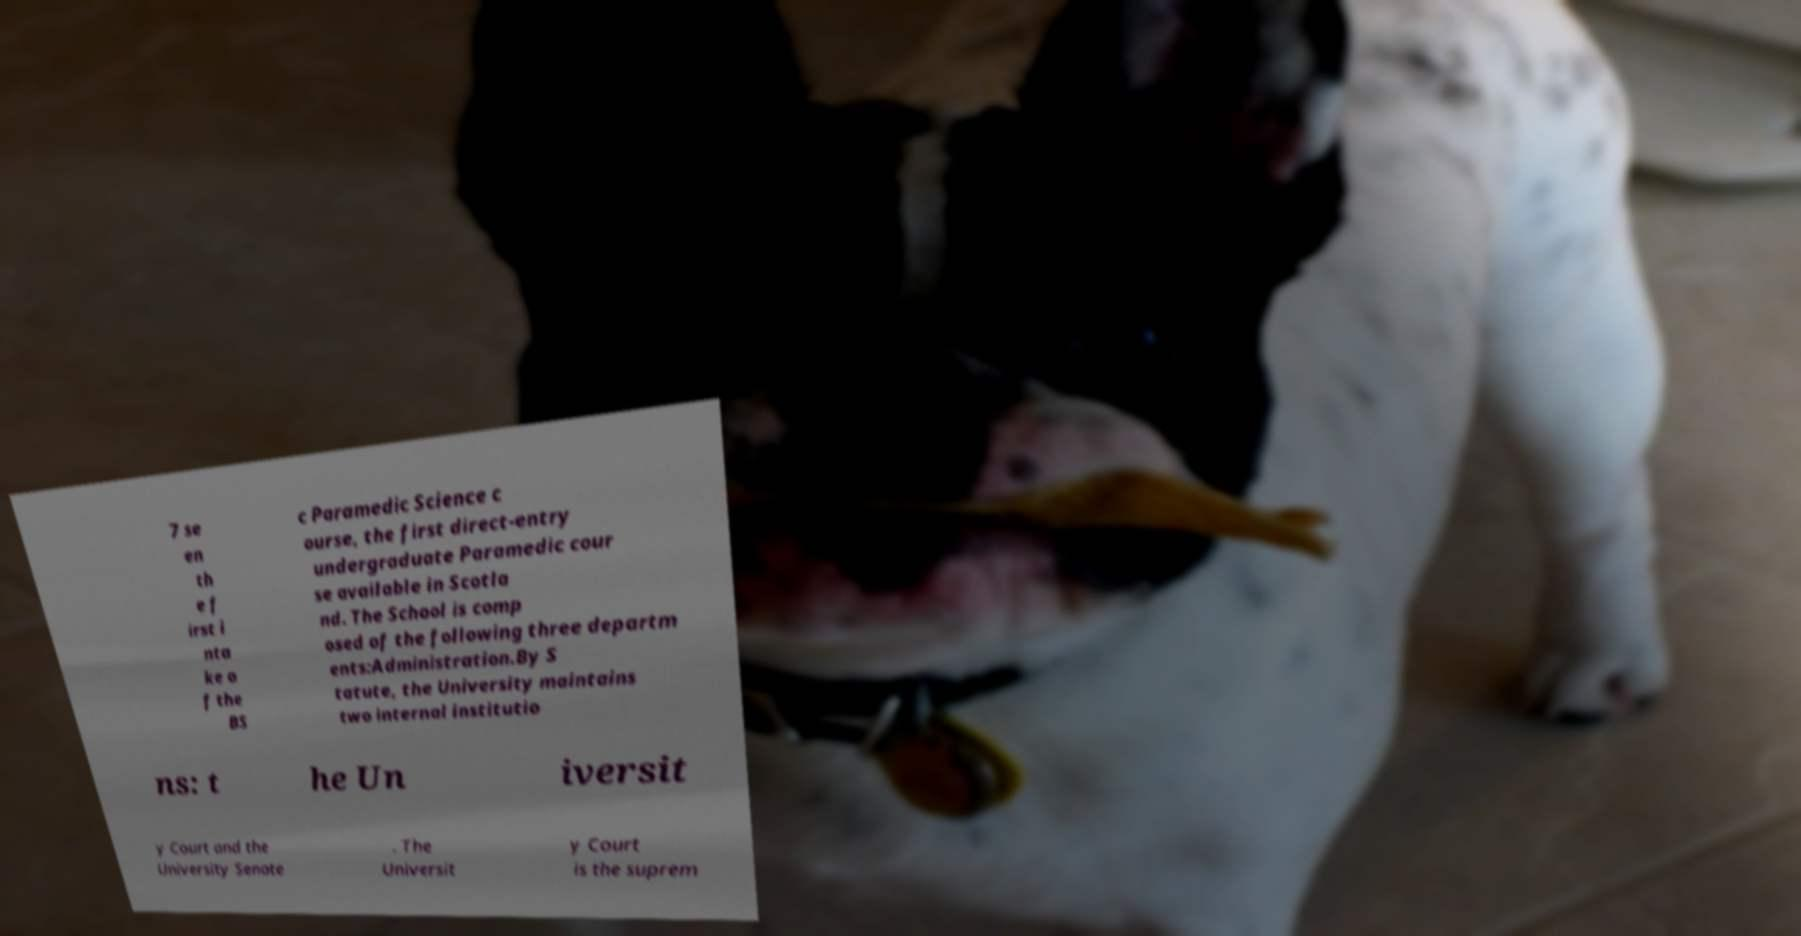Could you assist in decoding the text presented in this image and type it out clearly? 7 se en th e f irst i nta ke o f the BS c Paramedic Science c ourse, the first direct-entry undergraduate Paramedic cour se available in Scotla nd. The School is comp osed of the following three departm ents:Administration.By S tatute, the University maintains two internal institutio ns: t he Un iversit y Court and the University Senate . The Universit y Court is the suprem 